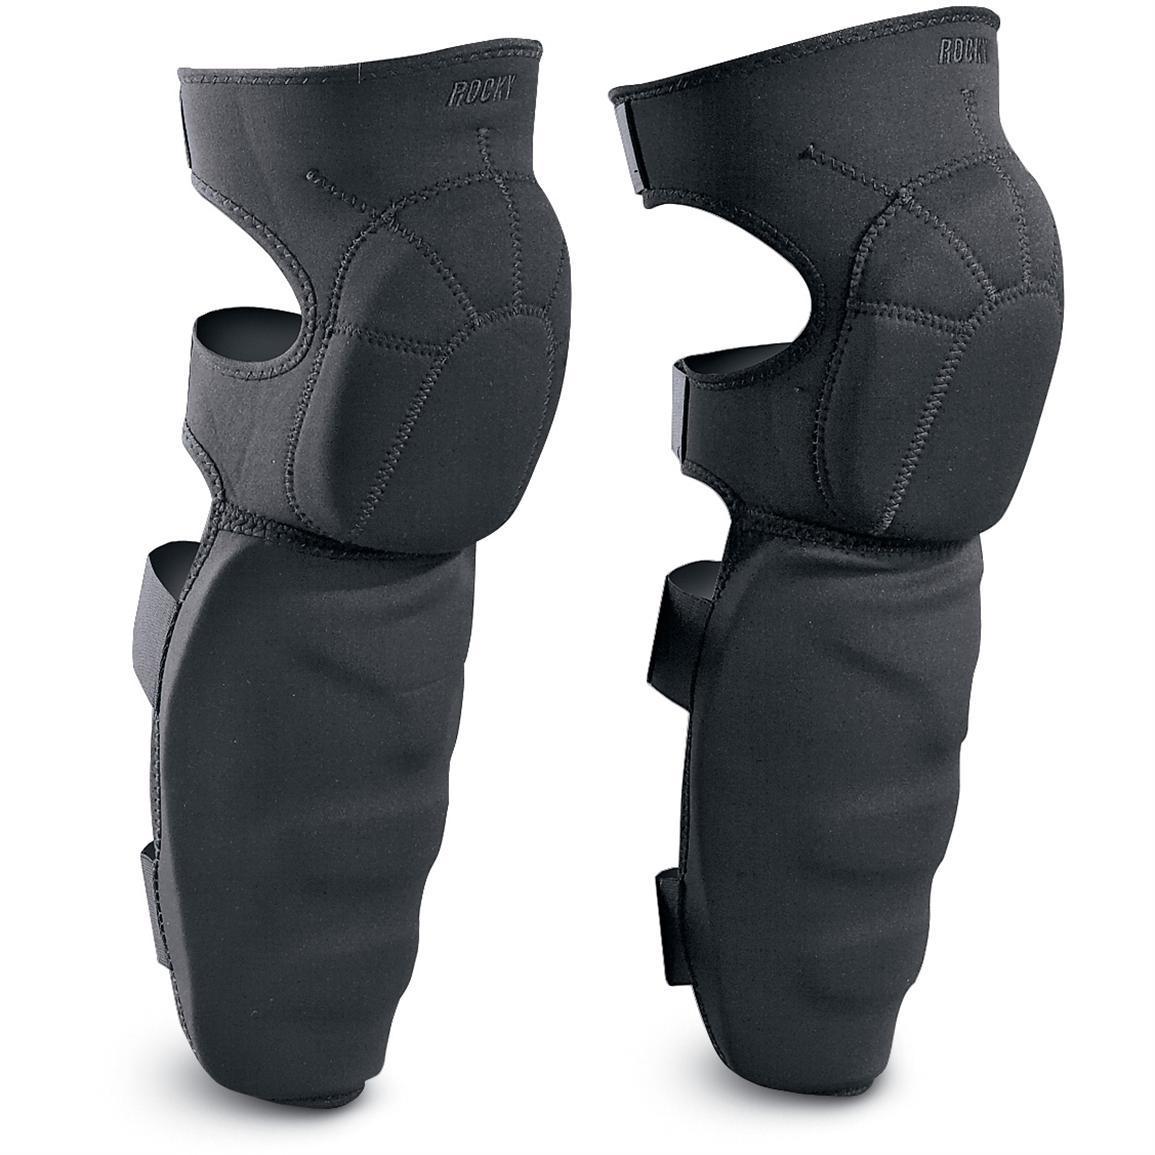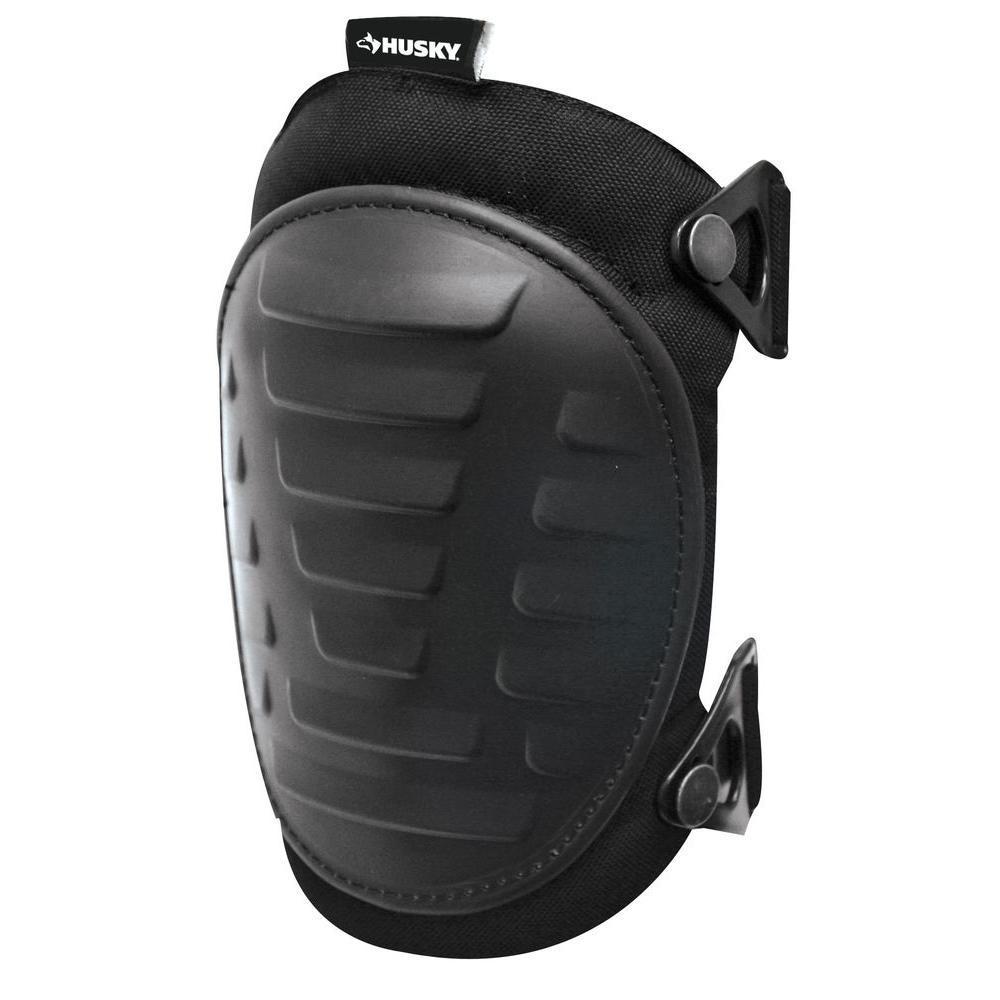The first image is the image on the left, the second image is the image on the right. For the images displayed, is the sentence "The combined images contain eight protective pads." factually correct? Answer yes or no. No. The first image is the image on the left, the second image is the image on the right. Evaluate the accuracy of this statement regarding the images: "There are more pads in the image on the left than in the image on the right.". Is it true? Answer yes or no. Yes. 